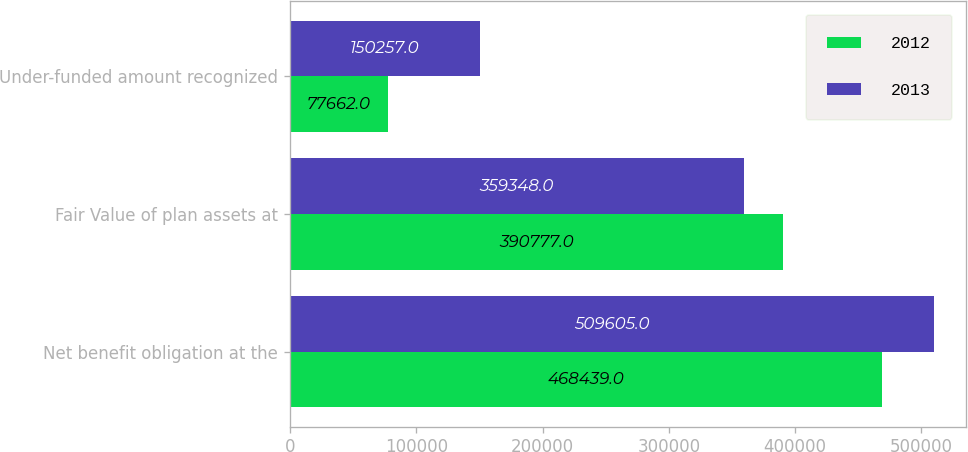<chart> <loc_0><loc_0><loc_500><loc_500><stacked_bar_chart><ecel><fcel>Net benefit obligation at the<fcel>Fair Value of plan assets at<fcel>Under-funded amount recognized<nl><fcel>2012<fcel>468439<fcel>390777<fcel>77662<nl><fcel>2013<fcel>509605<fcel>359348<fcel>150257<nl></chart> 